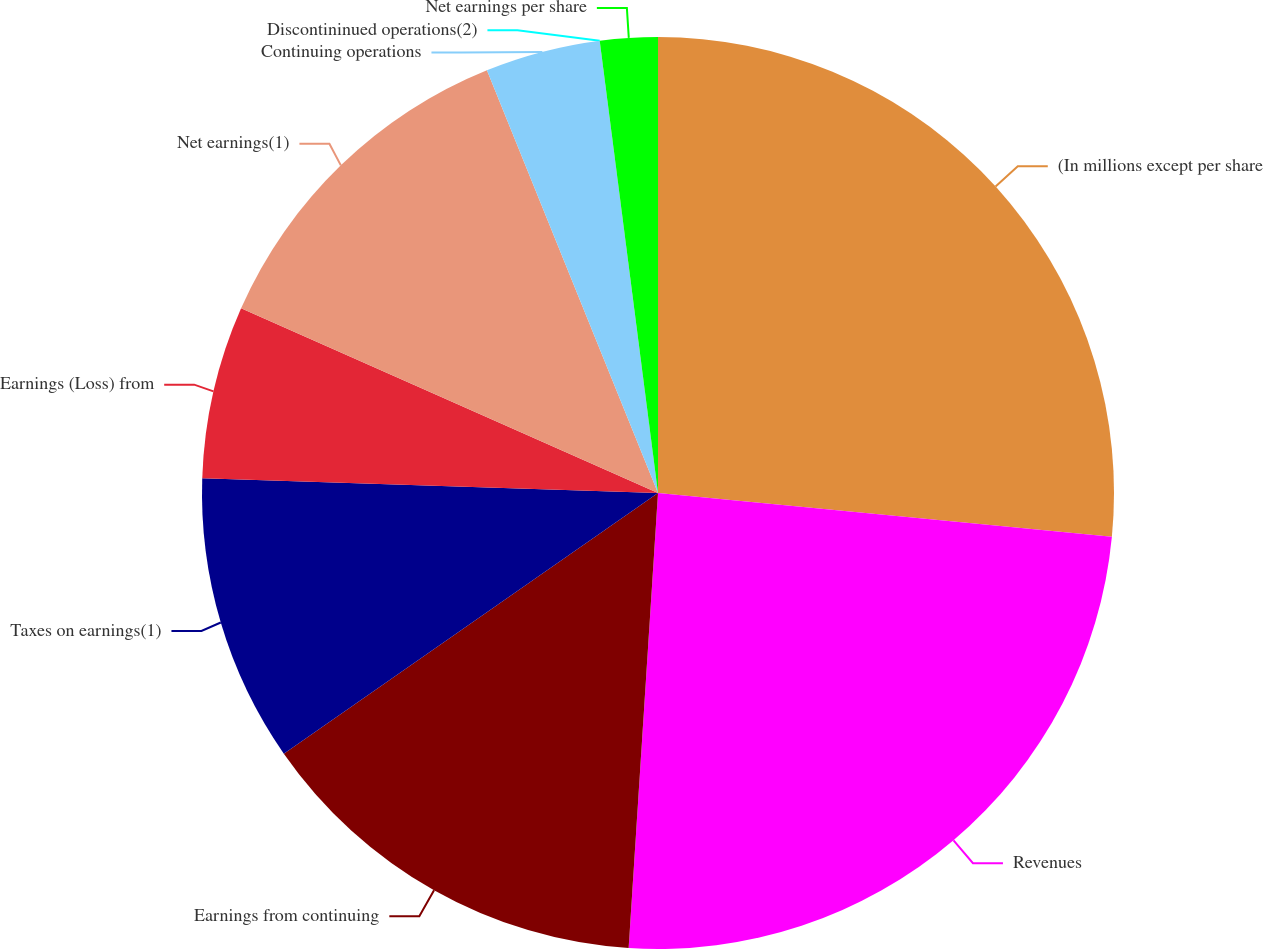Convert chart to OTSL. <chart><loc_0><loc_0><loc_500><loc_500><pie_chart><fcel>(In millions except per share<fcel>Revenues<fcel>Earnings from continuing<fcel>Taxes on earnings(1)<fcel>Earnings (Loss) from<fcel>Net earnings(1)<fcel>Continuing operations<fcel>Discontininued operations(2)<fcel>Net earnings per share<nl><fcel>26.53%<fcel>24.49%<fcel>14.29%<fcel>10.2%<fcel>6.12%<fcel>12.24%<fcel>4.08%<fcel>0.0%<fcel>2.04%<nl></chart> 